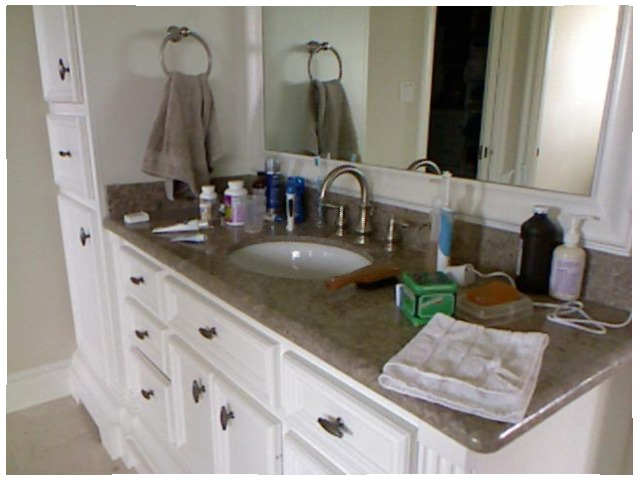<image>
Is the towel on the counter? No. The towel is not positioned on the counter. They may be near each other, but the towel is not supported by or resting on top of the counter. Is the soap behind the sink? No. The soap is not behind the sink. From this viewpoint, the soap appears to be positioned elsewhere in the scene. Is there a towel in the mirror? Yes. The towel is contained within or inside the mirror, showing a containment relationship. 